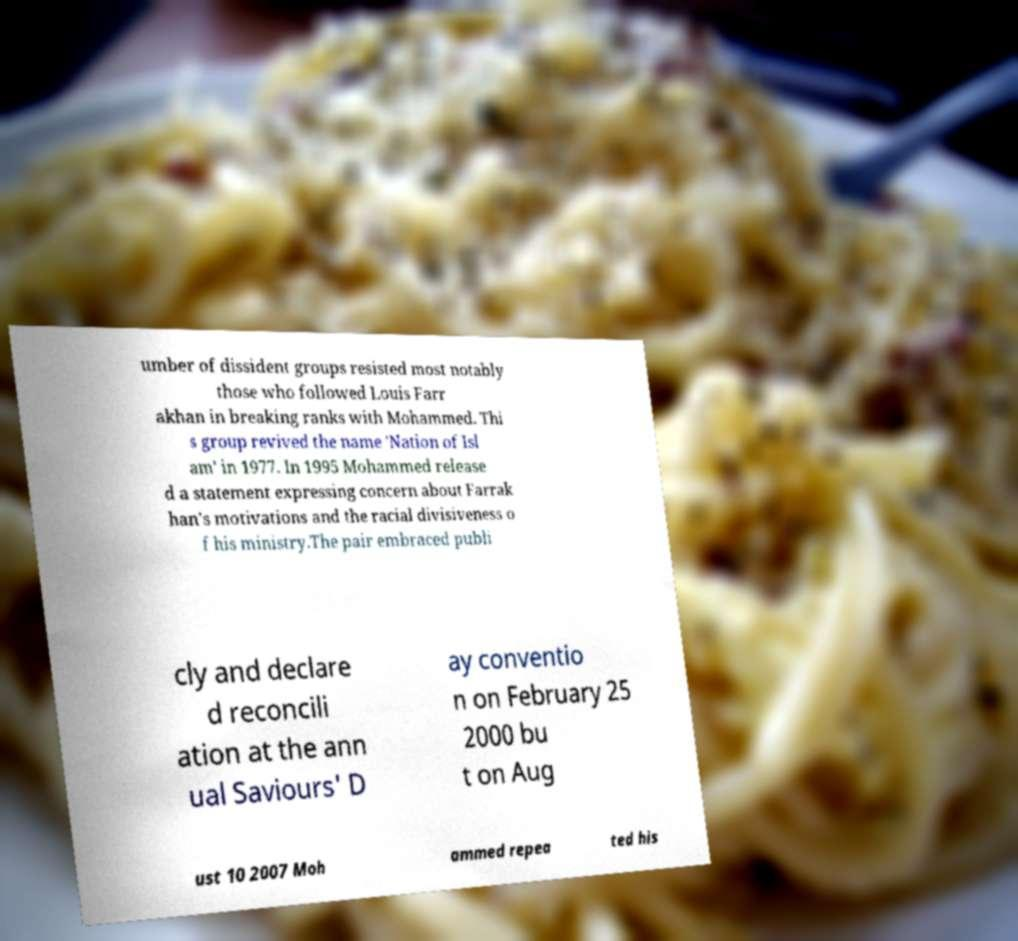Could you extract and type out the text from this image? umber of dissident groups resisted most notably those who followed Louis Farr akhan in breaking ranks with Mohammed. Thi s group revived the name 'Nation of Isl am' in 1977. In 1995 Mohammed release d a statement expressing concern about Farrak han's motivations and the racial divisiveness o f his ministry.The pair embraced publi cly and declare d reconcili ation at the ann ual Saviours' D ay conventio n on February 25 2000 bu t on Aug ust 10 2007 Moh ammed repea ted his 